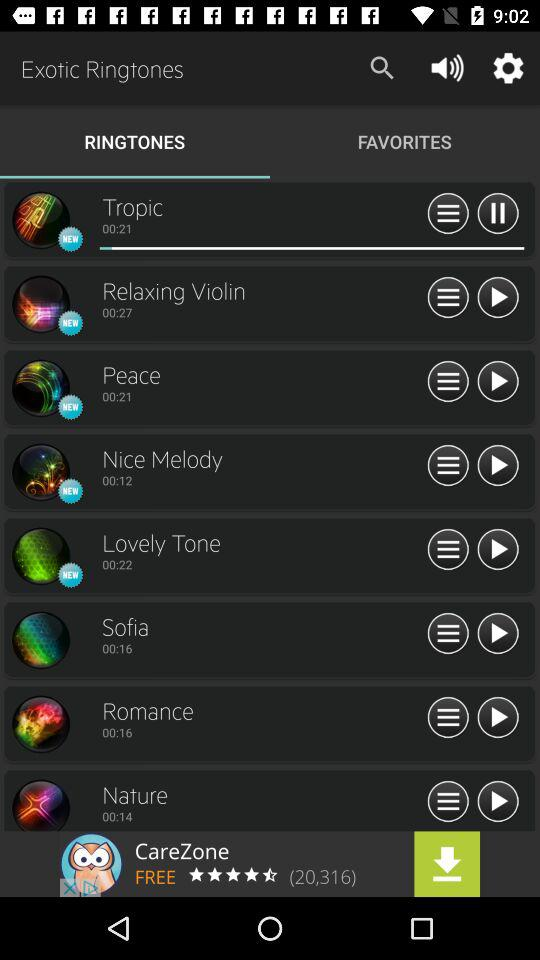Which tab has been selected? The selected tab is "RINGTONES". 